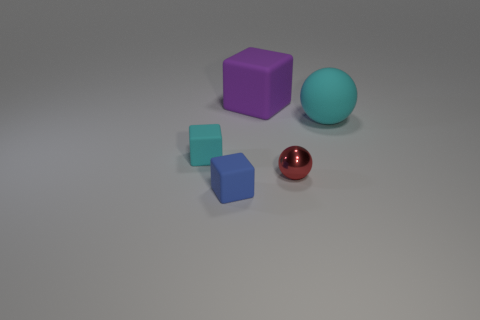Subtract all small blocks. How many blocks are left? 1 Add 2 large rubber blocks. How many objects exist? 7 Subtract all blue blocks. How many blocks are left? 2 Subtract 1 balls. How many balls are left? 1 Subtract all blocks. How many objects are left? 2 Subtract all green matte cubes. Subtract all red shiny things. How many objects are left? 4 Add 2 large purple matte cubes. How many large purple matte cubes are left? 3 Add 5 big cyan metal spheres. How many big cyan metal spheres exist? 5 Subtract 1 cyan cubes. How many objects are left? 4 Subtract all purple cubes. Subtract all red spheres. How many cubes are left? 2 